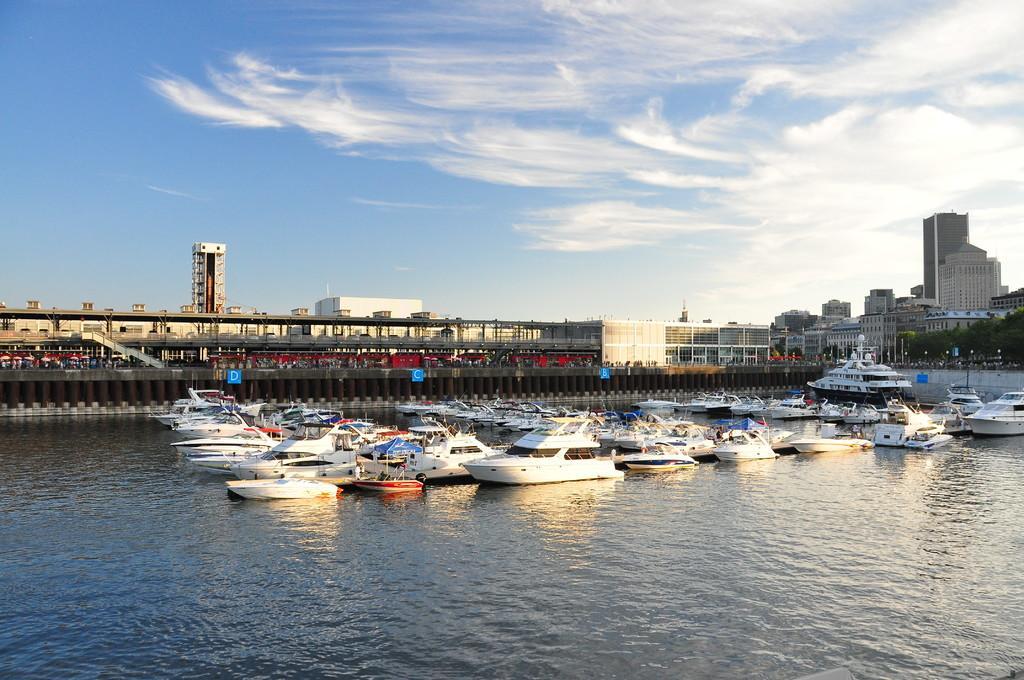In one or two sentences, can you explain what this image depicts? In this image I can see few ships,water,buildings,trees and blue color boards on the pillars. The sky is in blue and white color. 